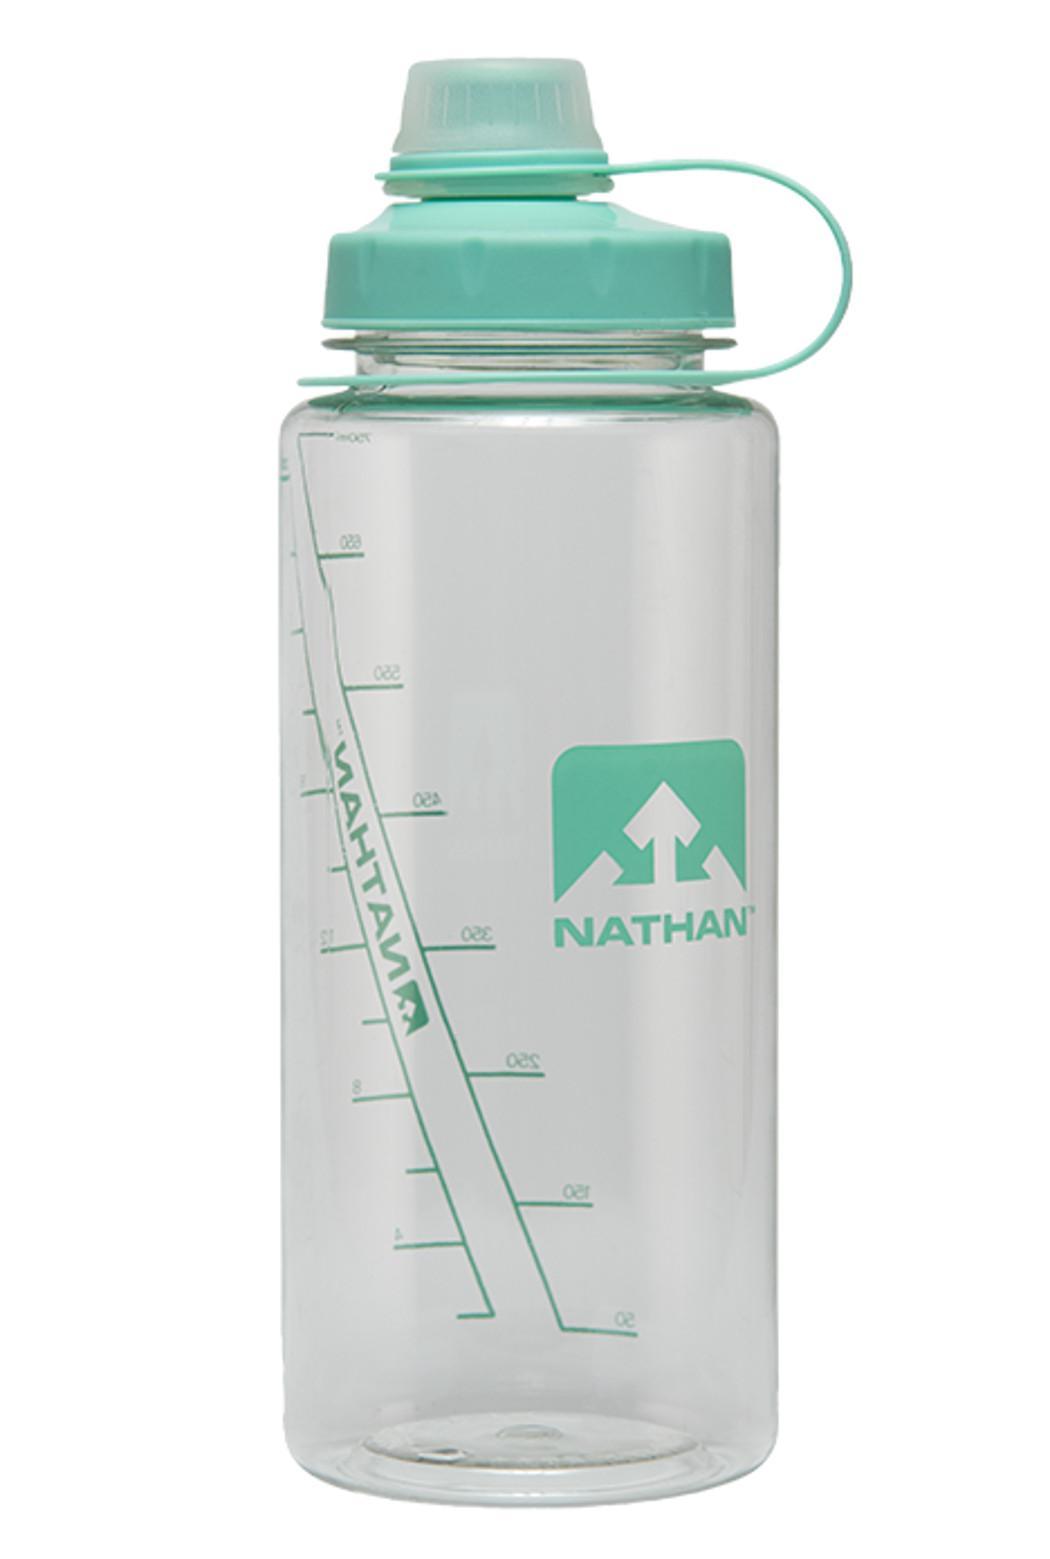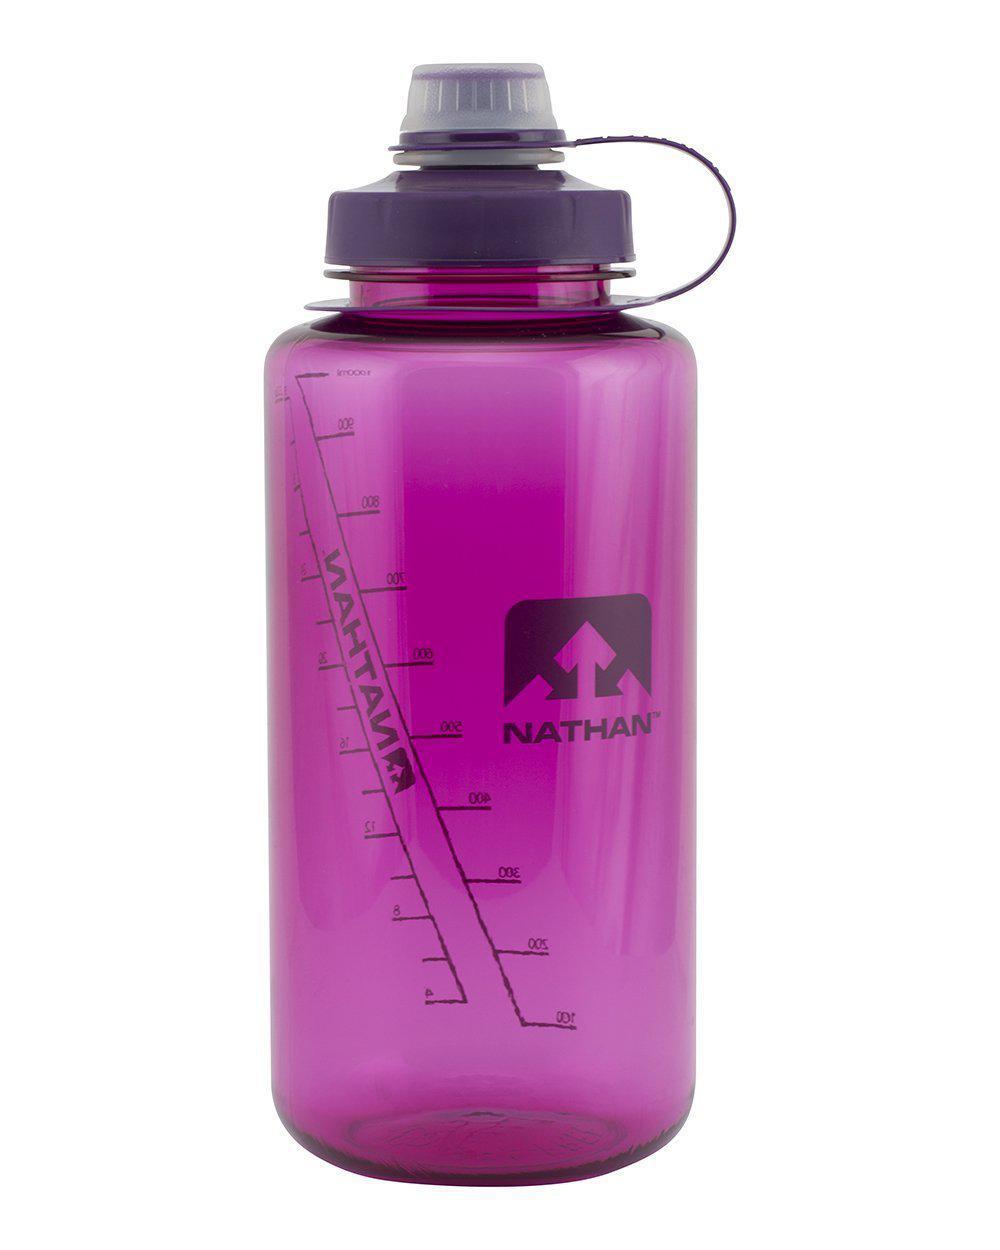The first image is the image on the left, the second image is the image on the right. Examine the images to the left and right. Is the description "Two bottles are closed." accurate? Answer yes or no. Yes. The first image is the image on the left, the second image is the image on the right. Examine the images to the left and right. Is the description "There are three water bottles in total." accurate? Answer yes or no. No. 